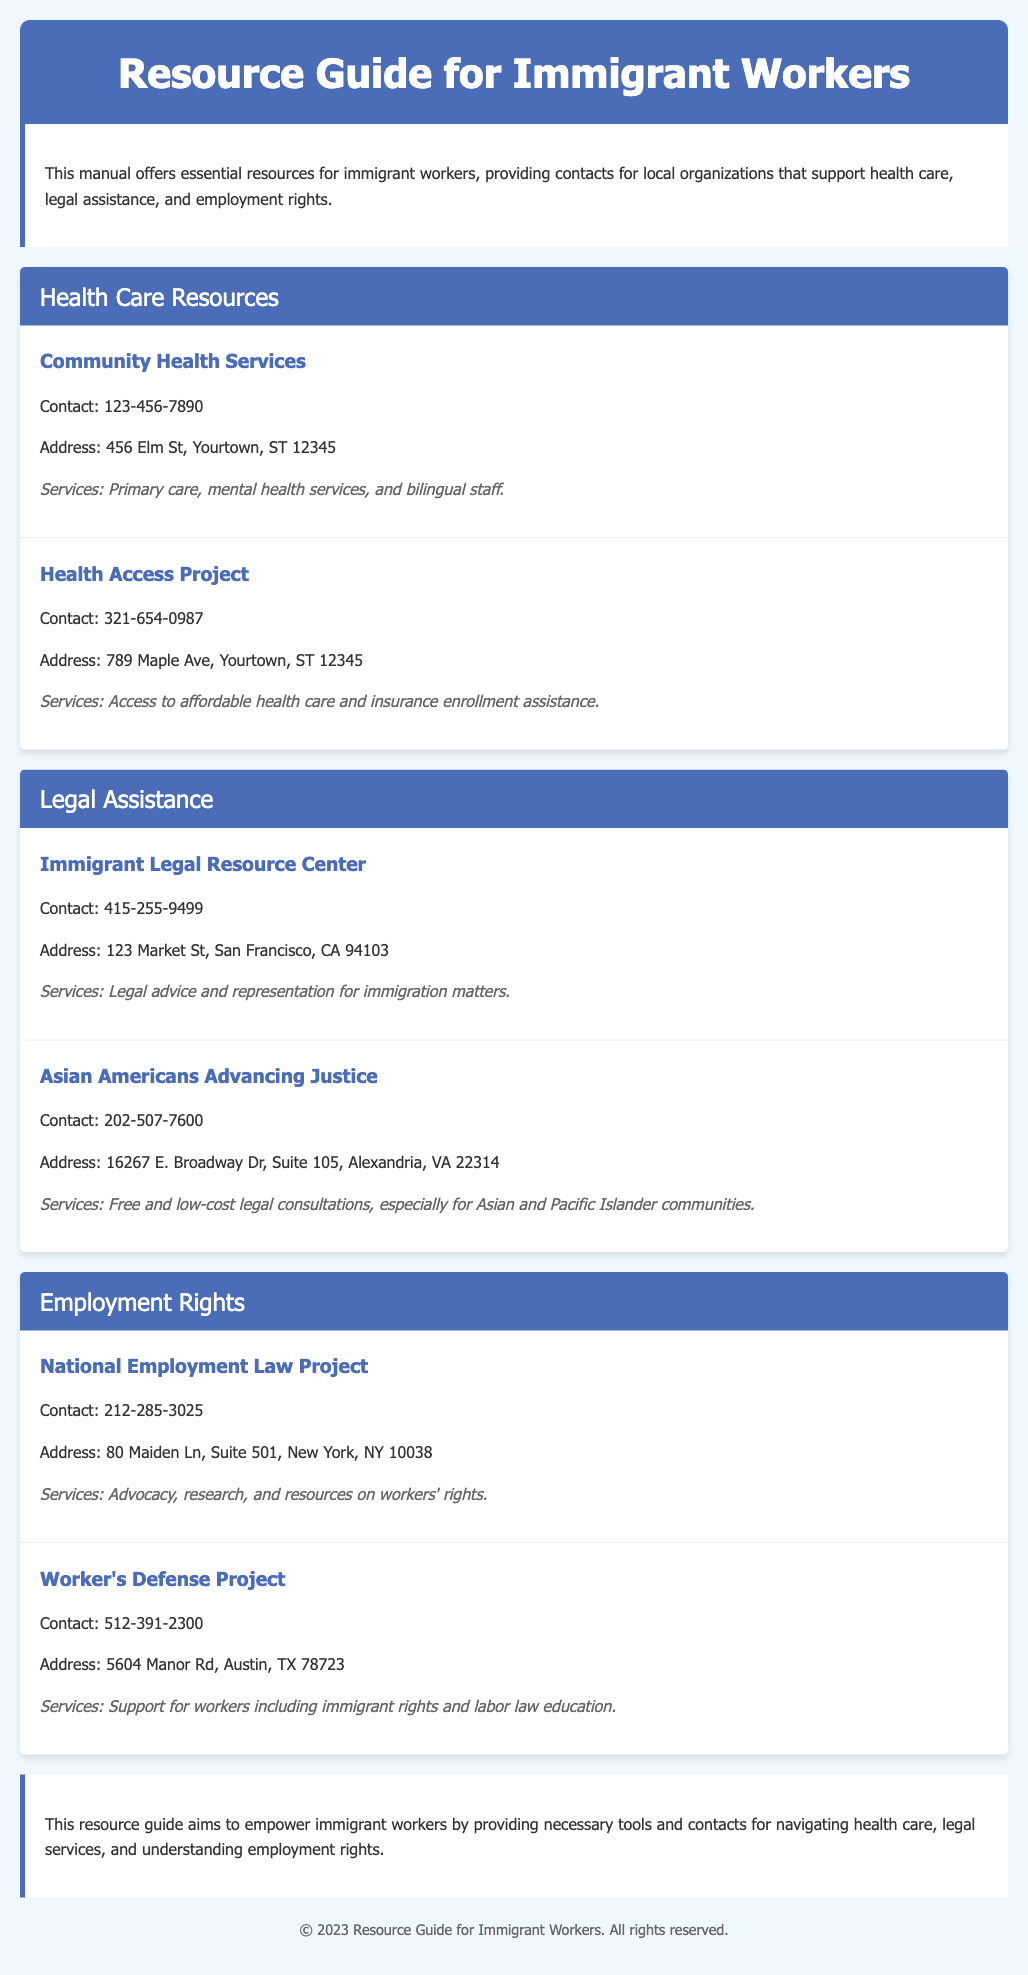what is the name of the first health care organization listed? The first health care organization in the document is "Community Health Services."
Answer: Community Health Services what is the contact number for the Immigrant Legal Resource Center? The contact number is explicitly stated under the organization in the legal assistance section.
Answer: 415-255-9499 how many organizations provide legal assistance in the document? The document lists the organizations in the legal assistance section, which shows there are two.
Answer: 2 what services does the Health Access Project provide? The services provided by the Health Access Project are listed in its details section.
Answer: Access to affordable health care and insurance enrollment assistance who is the target community for Asian Americans Advancing Justice? The target community is specified in the description of the organization.
Answer: Asian and Pacific Islander communities which section contains information about workers' rights? The section focused on employment rights is clearly titled in the document.
Answer: Employment Rights what is the address of the Worker’s Defense Project? The address can be found in the details provided for this organization.
Answer: 5604 Manor Rd, Austin, TX 78723 what is the purpose of this resource guide? The purpose of the resource guide is explained in the introduction and conclusion.
Answer: To empower immigrant workers how many sections are there in the document? The sections break down the types of resources and can be counted for their total.
Answer: 3 